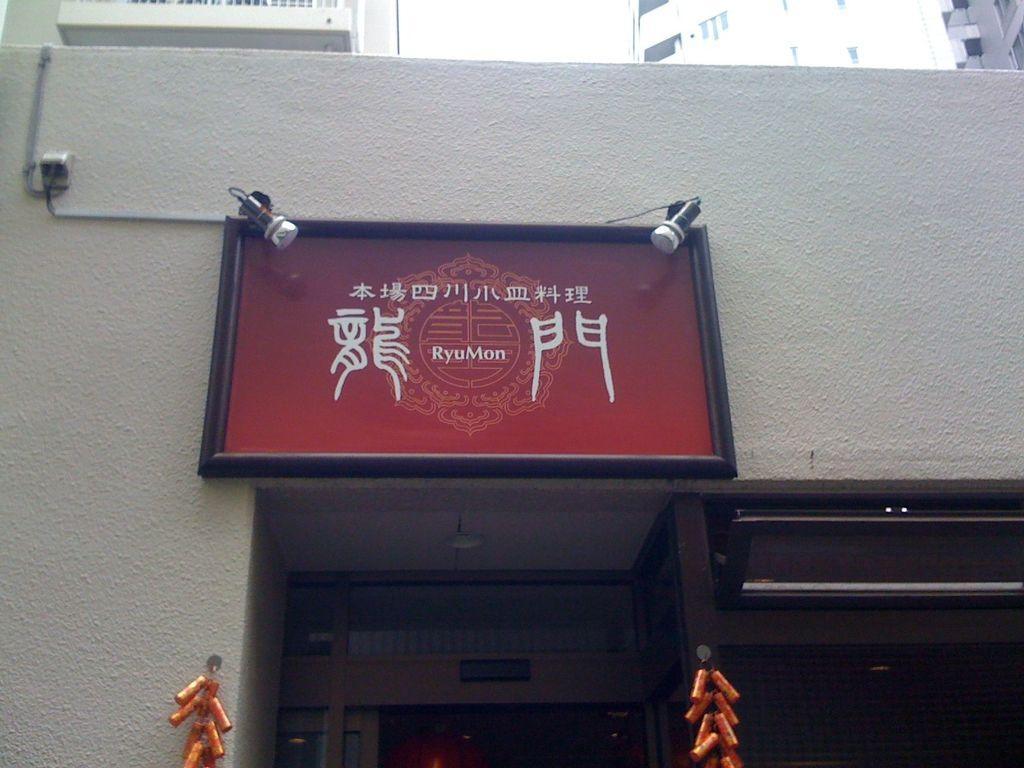Please provide a concise description of this image. In the middle of the picture, we see a red board with some text written on it. Behind that, we see a white wall and at the top of the picture, there are buildings which are in white color. At the bottom of the picture, we see decorative items in orange color and beside that, there is a rack in brown color. 